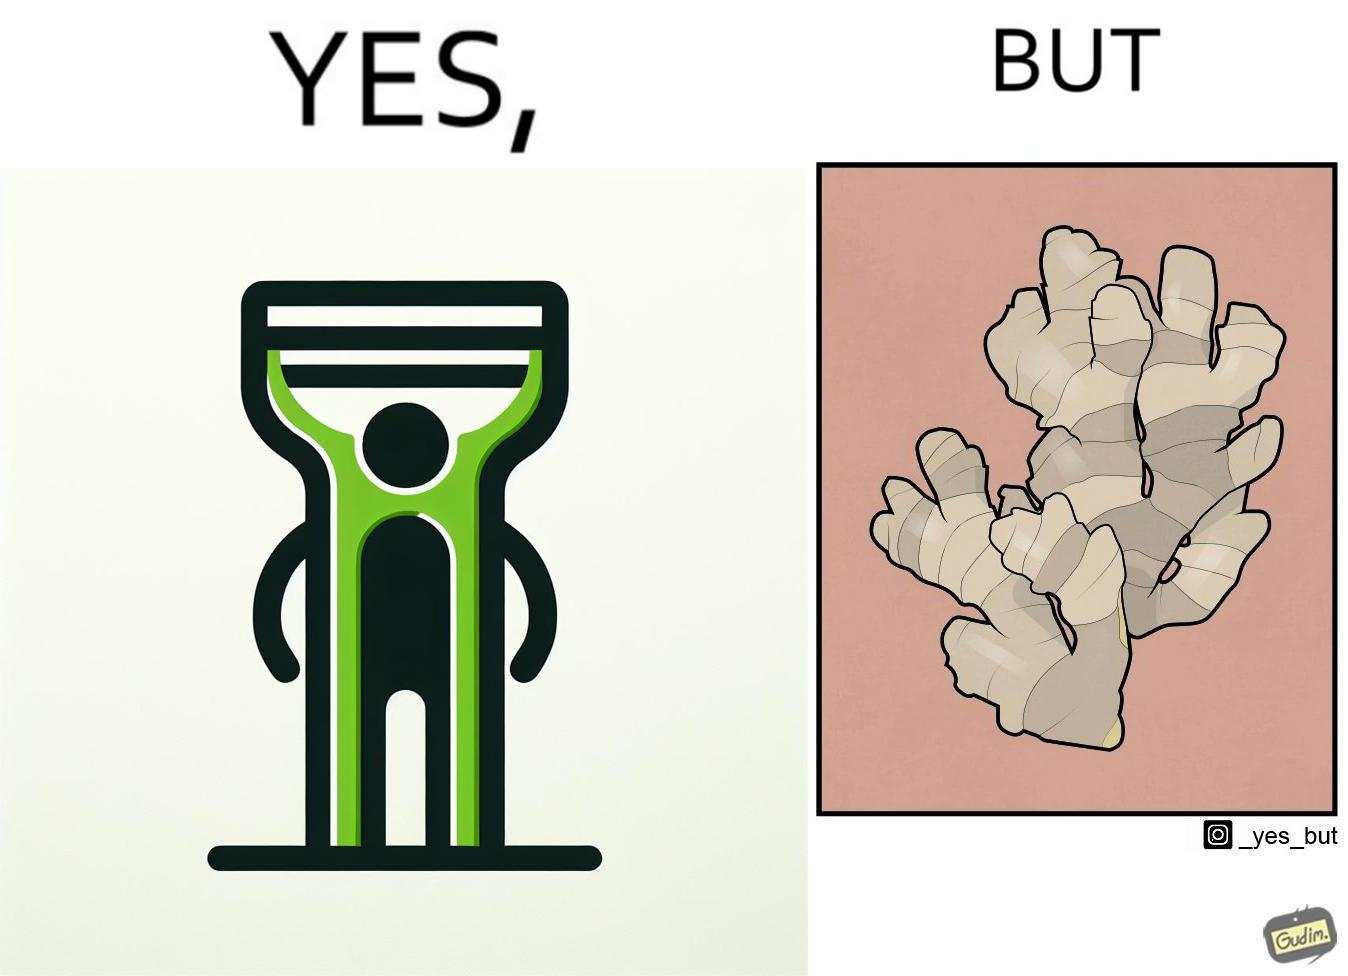Describe what you see in the left and right parts of this image. In the left part of the image: The image shows a green peeler. In the right part of the image: The image shows a ginger root with many branches and a complex shape. 